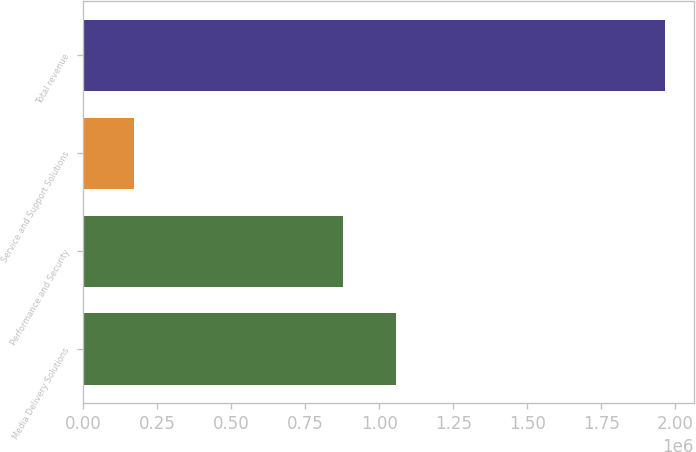Convert chart to OTSL. <chart><loc_0><loc_0><loc_500><loc_500><bar_chart><fcel>Media Delivery Solutions<fcel>Performance and Security<fcel>Service and Support Solutions<fcel>Total revenue<nl><fcel>1.05831e+06<fcel>879221<fcel>172938<fcel>1.96387e+06<nl></chart> 